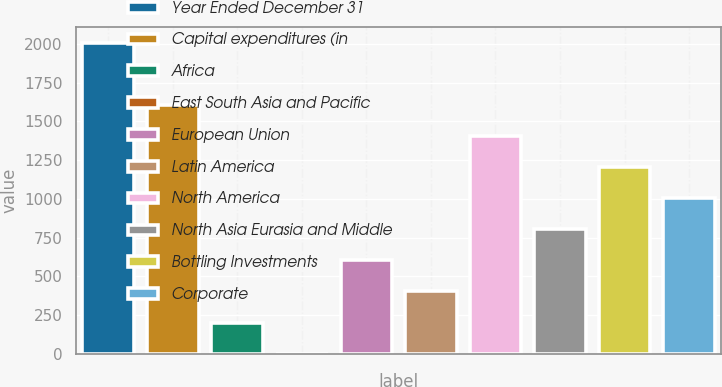Convert chart to OTSL. <chart><loc_0><loc_0><loc_500><loc_500><bar_chart><fcel>Year Ended December 31<fcel>Capital expenditures (in<fcel>Africa<fcel>East South Asia and Pacific<fcel>European Union<fcel>Latin America<fcel>North America<fcel>North Asia Eurasia and Middle<fcel>Bottling Investments<fcel>Corporate<nl><fcel>2006<fcel>1604.94<fcel>201.23<fcel>0.7<fcel>602.29<fcel>401.76<fcel>1404.41<fcel>802.82<fcel>1203.88<fcel>1003.35<nl></chart> 